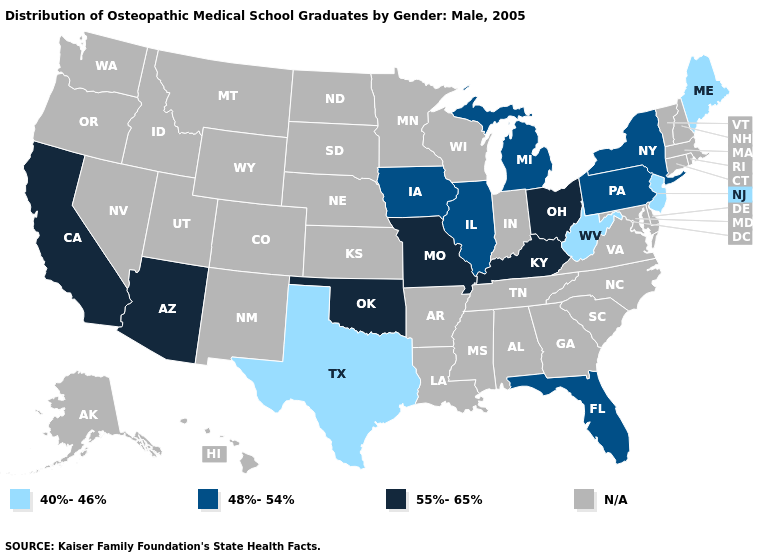Is the legend a continuous bar?
Give a very brief answer. No. What is the value of New York?
Give a very brief answer. 48%-54%. Which states hav the highest value in the West?
Quick response, please. Arizona, California. What is the value of Virginia?
Quick response, please. N/A. Does New Jersey have the lowest value in the Northeast?
Short answer required. Yes. What is the highest value in the USA?
Be succinct. 55%-65%. What is the value of Kentucky?
Short answer required. 55%-65%. Name the states that have a value in the range 40%-46%?
Short answer required. Maine, New Jersey, Texas, West Virginia. Which states have the lowest value in the South?
Be succinct. Texas, West Virginia. What is the value of California?
Be succinct. 55%-65%. Does Pennsylvania have the lowest value in the USA?
Write a very short answer. No. What is the value of Virginia?
Short answer required. N/A. What is the value of North Carolina?
Write a very short answer. N/A. What is the value of Oregon?
Concise answer only. N/A. 